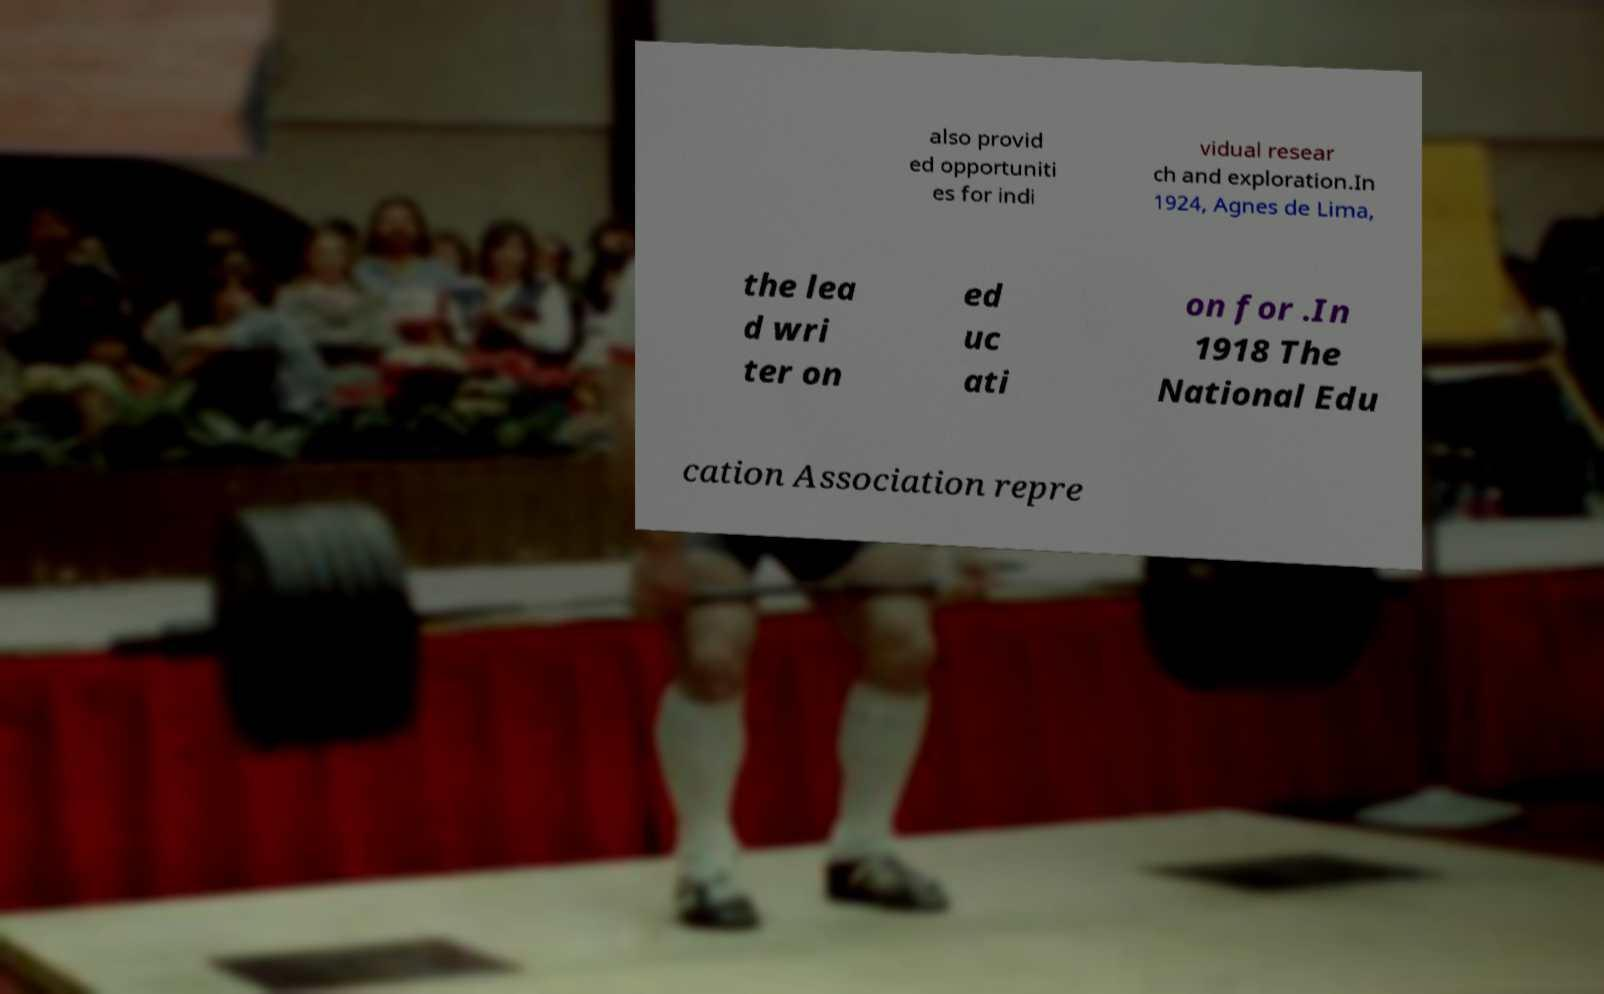For documentation purposes, I need the text within this image transcribed. Could you provide that? also provid ed opportuniti es for indi vidual resear ch and exploration.In 1924, Agnes de Lima, the lea d wri ter on ed uc ati on for .In 1918 The National Edu cation Association repre 